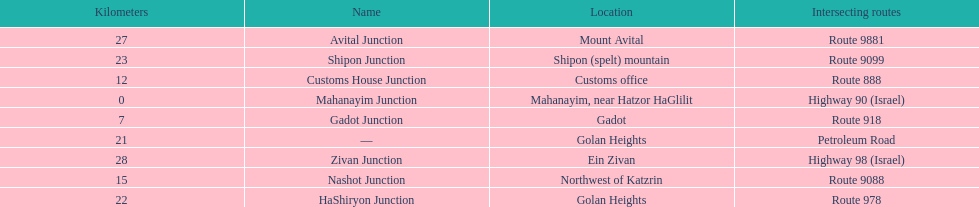Parse the table in full. {'header': ['Kilometers', 'Name', 'Location', 'Intersecting routes'], 'rows': [['27', 'Avital Junction', 'Mount Avital', 'Route 9881'], ['23', 'Shipon Junction', 'Shipon (spelt) mountain', 'Route 9099'], ['12', 'Customs House Junction', 'Customs office', 'Route 888'], ['0', 'Mahanayim Junction', 'Mahanayim, near Hatzor HaGlilit', 'Highway 90 (Israel)'], ['7', 'Gadot Junction', 'Gadot', 'Route 918'], ['21', '—', 'Golan Heights', 'Petroleum Road'], ['28', 'Zivan Junction', 'Ein Zivan', 'Highway 98 (Israel)'], ['15', 'Nashot Junction', 'Northwest of Katzrin', 'Route 9088'], ['22', 'HaShiryon Junction', 'Golan Heights', 'Route 978']]} What junction is the furthest from mahanayim junction? Zivan Junction. 